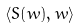Convert formula to latex. <formula><loc_0><loc_0><loc_500><loc_500>\langle S ( w ) , w \rangle</formula> 